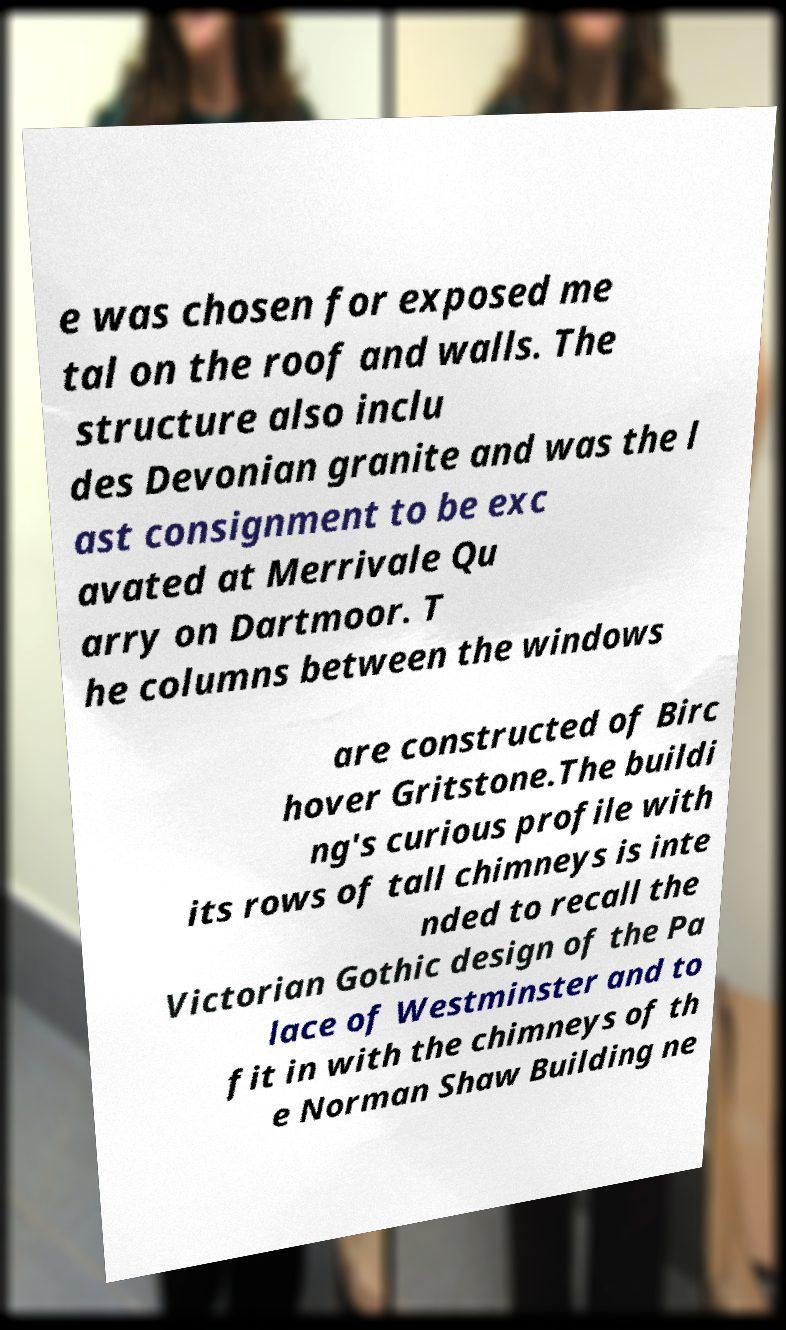There's text embedded in this image that I need extracted. Can you transcribe it verbatim? e was chosen for exposed me tal on the roof and walls. The structure also inclu des Devonian granite and was the l ast consignment to be exc avated at Merrivale Qu arry on Dartmoor. T he columns between the windows are constructed of Birc hover Gritstone.The buildi ng's curious profile with its rows of tall chimneys is inte nded to recall the Victorian Gothic design of the Pa lace of Westminster and to fit in with the chimneys of th e Norman Shaw Building ne 